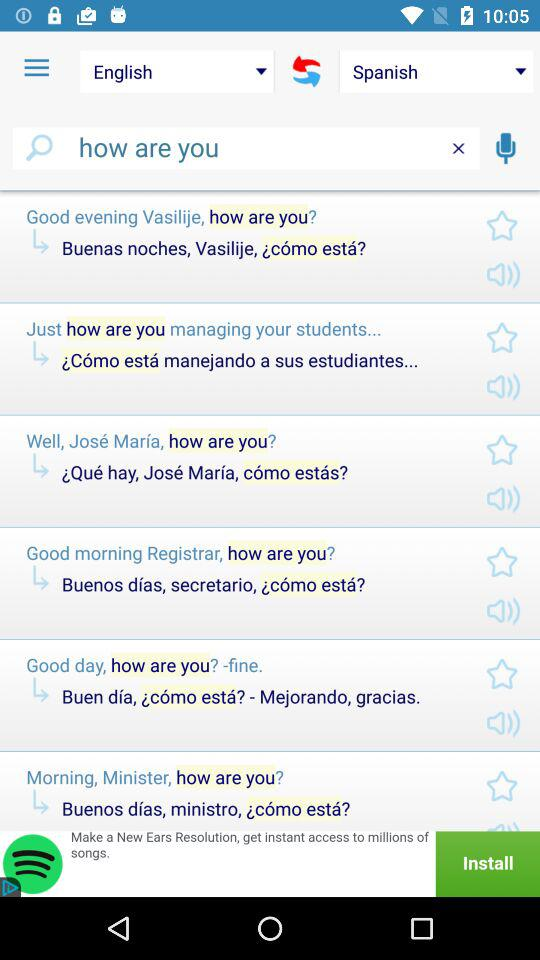What is the text entered to translate into Spanish? The text that is entered to translate into Spanish is "how are you". 